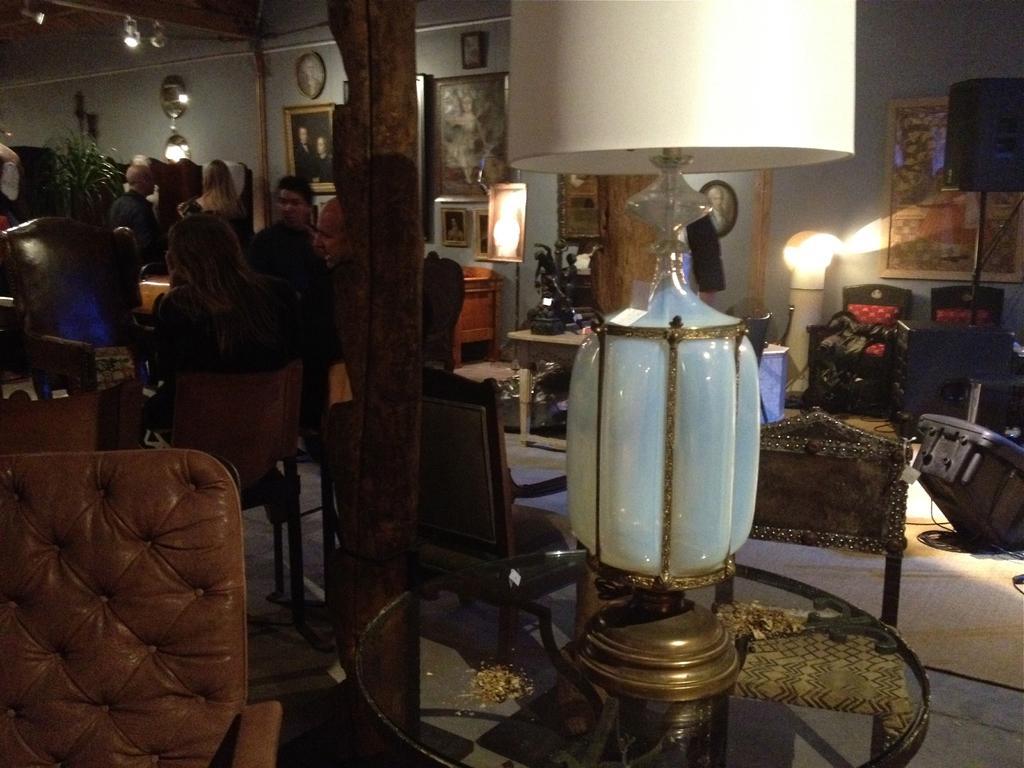Could you give a brief overview of what you see in this image? In this image on the left side few people are sitting on the chairs. In the middle there is a glass bulb on the table. On the right side there are photo frames on this wall. 